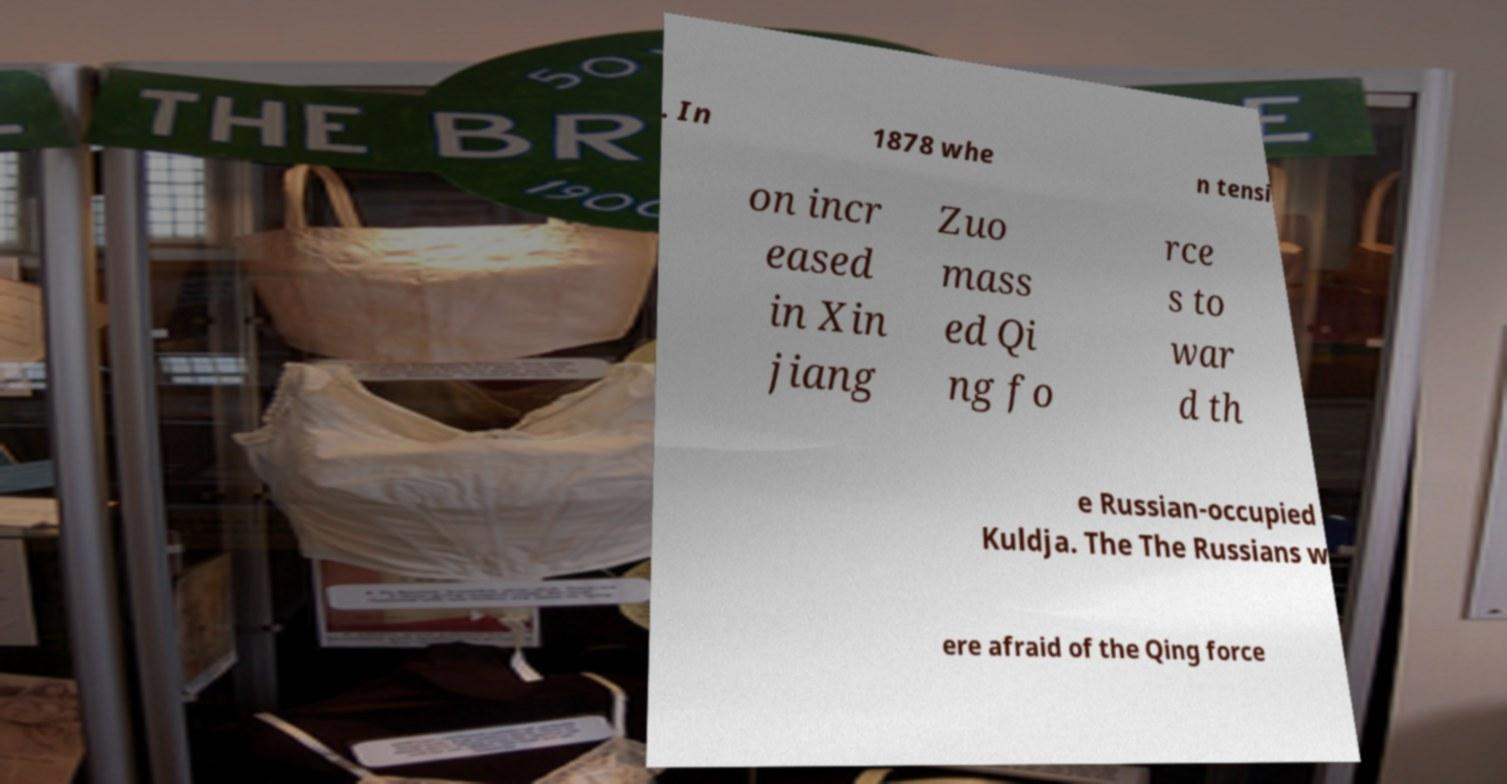Could you extract and type out the text from this image? . In 1878 whe n tensi on incr eased in Xin jiang Zuo mass ed Qi ng fo rce s to war d th e Russian-occupied Kuldja. The The Russians w ere afraid of the Qing force 